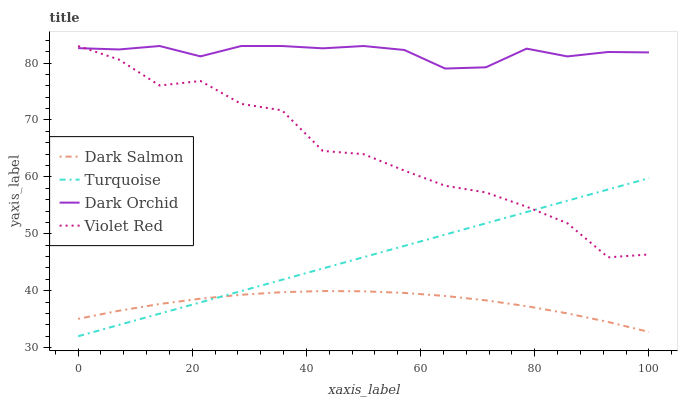Does Dark Salmon have the minimum area under the curve?
Answer yes or no. Yes. Does Dark Orchid have the maximum area under the curve?
Answer yes or no. Yes. Does Turquoise have the minimum area under the curve?
Answer yes or no. No. Does Turquoise have the maximum area under the curve?
Answer yes or no. No. Is Turquoise the smoothest?
Answer yes or no. Yes. Is Violet Red the roughest?
Answer yes or no. Yes. Is Dark Salmon the smoothest?
Answer yes or no. No. Is Dark Salmon the roughest?
Answer yes or no. No. Does Turquoise have the lowest value?
Answer yes or no. Yes. Does Dark Salmon have the lowest value?
Answer yes or no. No. Does Dark Orchid have the highest value?
Answer yes or no. Yes. Does Turquoise have the highest value?
Answer yes or no. No. Is Dark Salmon less than Dark Orchid?
Answer yes or no. Yes. Is Dark Orchid greater than Dark Salmon?
Answer yes or no. Yes. Does Turquoise intersect Dark Salmon?
Answer yes or no. Yes. Is Turquoise less than Dark Salmon?
Answer yes or no. No. Is Turquoise greater than Dark Salmon?
Answer yes or no. No. Does Dark Salmon intersect Dark Orchid?
Answer yes or no. No. 